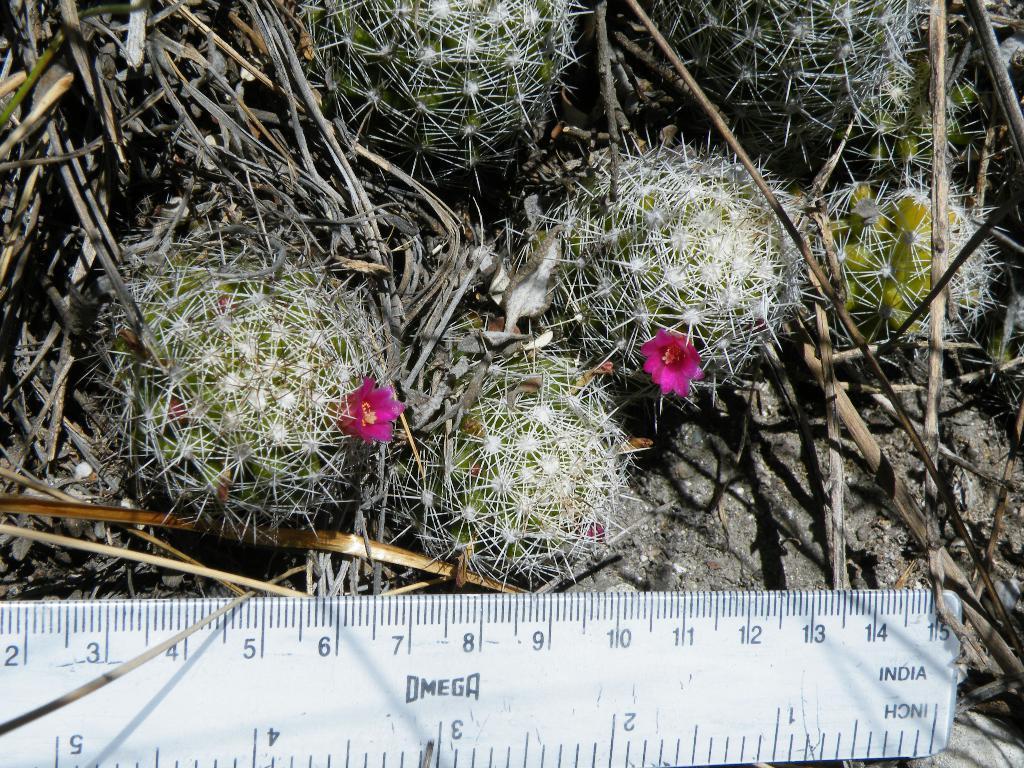Please provide a concise description of this image. Here in this picture we can see plants on the ground present over there and we can see flowers here and there in the plants and at the bottom we can see a white colored scale present over there. 